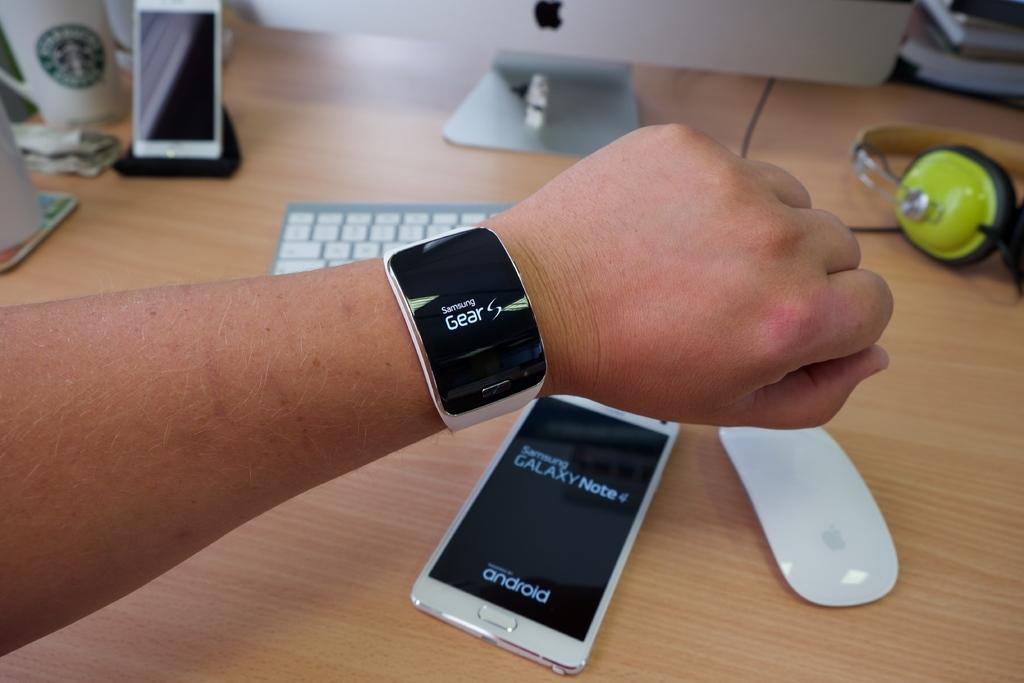<image>
Offer a succinct explanation of the picture presented. A person wearing a Samsung Gear watch holds its above a Samsung mobile as if to demonstrate that the two can work in tandem. 